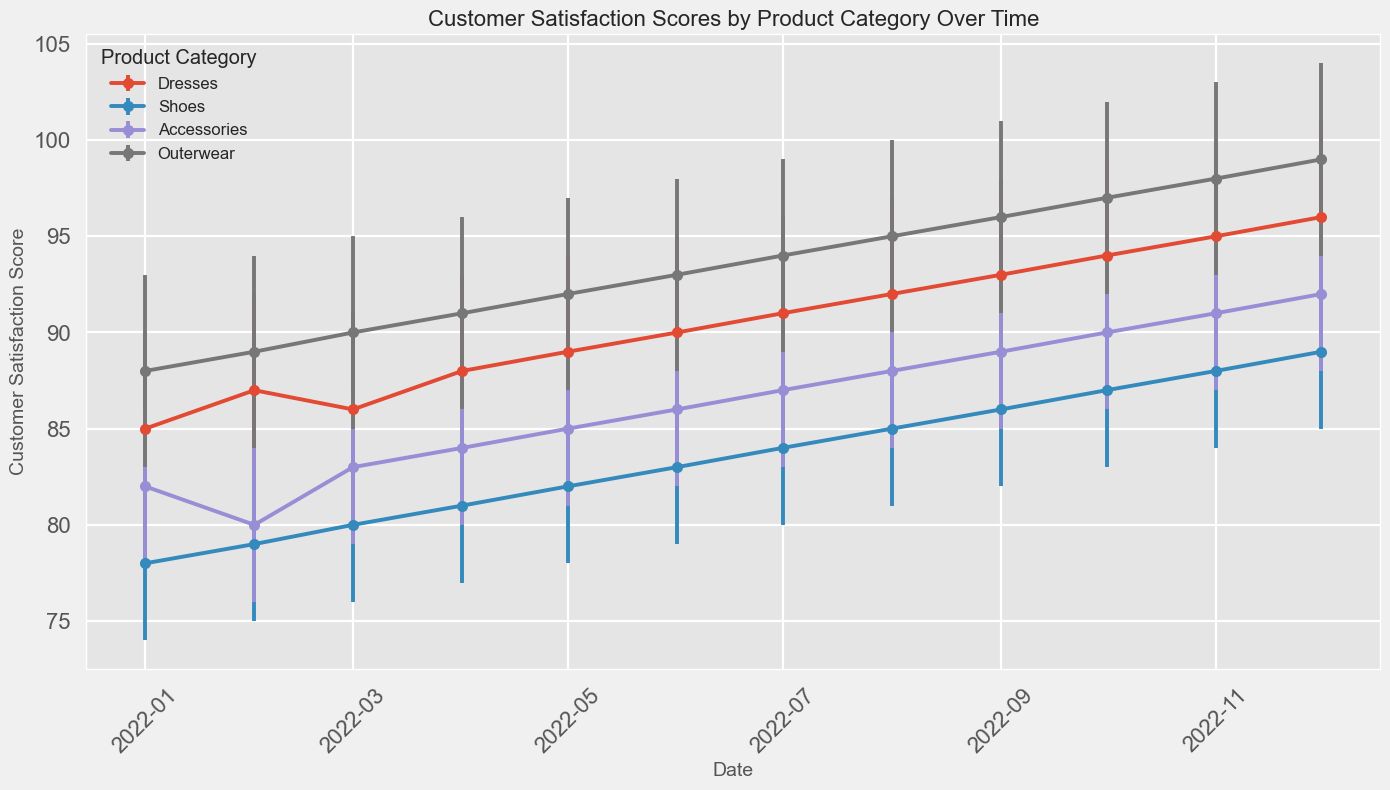Which product category has the highest customer satisfaction score in December 2022? In December 2022, Dresses have the highest score of 96 compared to the other categories (Shoes: 89, Accessories: 92, Outerwear: 99).
Answer: Outerwear Over the entire year, which product category shows the most consistent increase in customer satisfaction scores? By observing the trend lines, we see Outerwear consistently increases from 88 in January to 99 in December. Other categories also increase, but not as steadily.
Answer: Outerwear What are the confidence intervals for Dresses in March 2022? The plot shows that in March 2022, the score for Dresses is 86 with error bars indicating a lower bound of 81 and an upper bound of 91.
Answer: 81-91 What is the average customer satisfaction score for Accessories from January to December 2022? The scores are 82, 80, 83, 84, 85, 86, 87, 88, 89, 90, 91, and 92 respectively. Sum these scores to get 1027, and then divide by 12 months: 1027/12 ≈ 85.58.
Answer: 85.58 Which two months have the smallest difference in customer satisfaction scores for Shoes? The smallest difference can be found by looking at the plot and finding adjacent months where the score difference is the least. January (78) to February (79), the difference is just 1 point.
Answer: January to February Which month shows the largest confidence interval for Outerwear? The largest error bar for Outerwear can be visually estimated. The error bar in December (99, CI: 94-104) shows the largest interval, 104 - 94 = 10 points.
Answer: December Are there any months where the customer satisfaction score for Accessories is exactly equidistant between the lower and upper confidence intervals? Each month’s confidence interval for Accessories should be checked to find if the score equals the midpoint between CI lower and upper bounds. For instance, November (91 score, CI: 87-95), the score is right in the middle.
Answer: November By how much did the customer satisfaction score for Shoes increase from January to December 2022? The score for Shoes in January is 78, and in December it is 89. The difference is: 89 - 78 = 11 points.
Answer: 11 In which month did Dresses exceed 90 in customer satisfaction score for the first time? By checking the timeline, we see Dresses exceeded 90 in August with a score of 92.
Answer: August What is the trend of customer satisfaction for Shoes throughout the year 2022? The customer satisfaction for Shoes shows a gradually increasing trend from 78 in January to 89 in December. The plot indicates a steady rise.
Answer: Increasing 